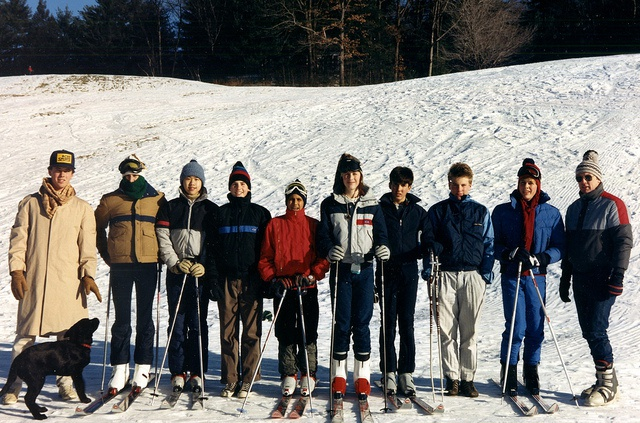Describe the objects in this image and their specific colors. I can see people in black, tan, and gray tones, people in black, gray, lightgray, and navy tones, people in black, gray, beige, and darkgray tones, people in black, lightgray, darkgray, and gray tones, and people in black, tan, ivory, and maroon tones in this image. 